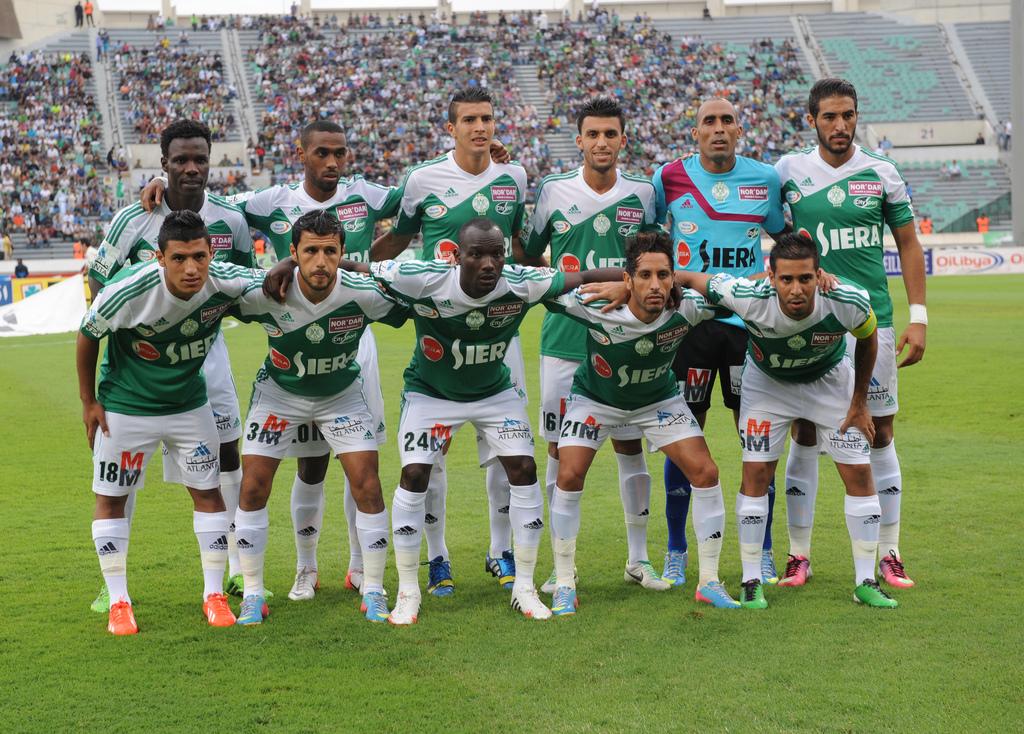Who is playing the game?
Offer a very short reply. Siera. What number is the man in the middle?
Ensure brevity in your answer.  24. 